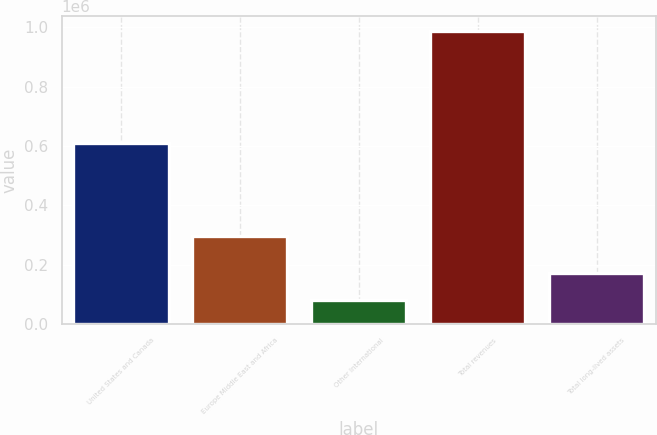<chart> <loc_0><loc_0><loc_500><loc_500><bar_chart><fcel>United States and Canada<fcel>Europe Middle East and Africa<fcel>Other International<fcel>Total revenues<fcel>Total long-lived assets<nl><fcel>610980<fcel>296705<fcel>81319<fcel>989004<fcel>172088<nl></chart> 